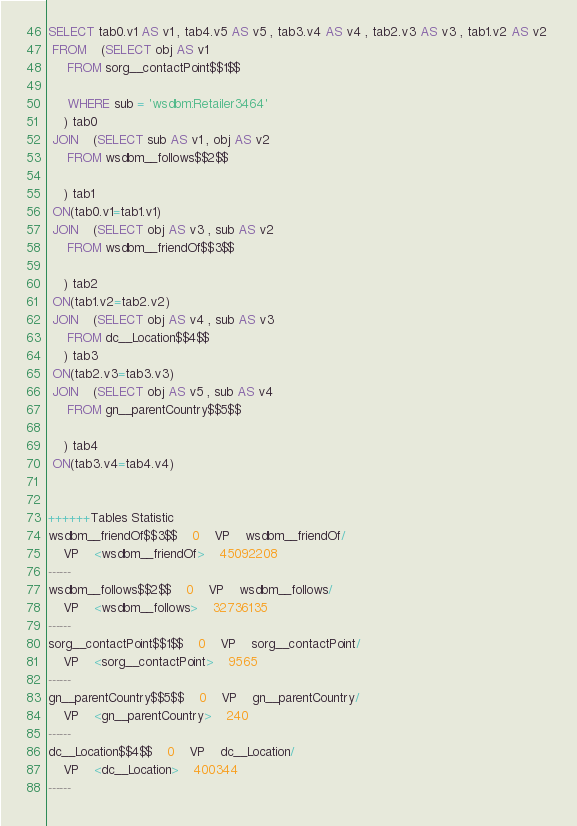Convert code to text. <code><loc_0><loc_0><loc_500><loc_500><_SQL_>SELECT tab0.v1 AS v1 , tab4.v5 AS v5 , tab3.v4 AS v4 , tab2.v3 AS v3 , tab1.v2 AS v2 
 FROM    (SELECT obj AS v1 
	 FROM sorg__contactPoint$$1$$
	 
	 WHERE sub = 'wsdbm:Retailer3464'
	) tab0
 JOIN    (SELECT sub AS v1 , obj AS v2 
	 FROM wsdbm__follows$$2$$
	
	) tab1
 ON(tab0.v1=tab1.v1)
 JOIN    (SELECT obj AS v3 , sub AS v2 
	 FROM wsdbm__friendOf$$3$$
	
	) tab2
 ON(tab1.v2=tab2.v2)
 JOIN    (SELECT obj AS v4 , sub AS v3 
	 FROM dc__Location$$4$$
	) tab3
 ON(tab2.v3=tab3.v3)
 JOIN    (SELECT obj AS v5 , sub AS v4 
	 FROM gn__parentCountry$$5$$
	
	) tab4
 ON(tab3.v4=tab4.v4)


++++++Tables Statistic
wsdbm__friendOf$$3$$	0	VP	wsdbm__friendOf/
	VP	<wsdbm__friendOf>	45092208
------
wsdbm__follows$$2$$	0	VP	wsdbm__follows/
	VP	<wsdbm__follows>	32736135
------
sorg__contactPoint$$1$$	0	VP	sorg__contactPoint/
	VP	<sorg__contactPoint>	9565
------
gn__parentCountry$$5$$	0	VP	gn__parentCountry/
	VP	<gn__parentCountry>	240
------
dc__Location$$4$$	0	VP	dc__Location/
	VP	<dc__Location>	400344
------
</code> 